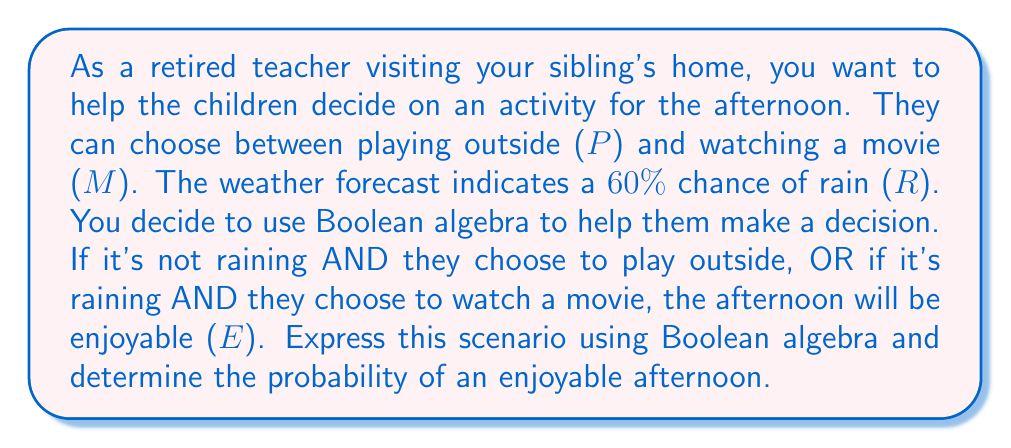Could you help me with this problem? Let's approach this step-by-step using Boolean algebra:

1. Define the variables:
   P: Playing outside
   M: Watching a movie
   R: Raining
   E: Enjoyable afternoon

2. Express the scenario in Boolean algebra:
   $E = (P \land \overline{R}) \lor (M \land R)$

3. We know the probability of rain is 60%, so:
   $P(R) = 0.6$
   $P(\overline{R}) = 1 - P(R) = 0.4$

4. Assume the children are equally likely to choose playing outside or watching a movie:
   $P(P) = P(M) = 0.5$

5. Calculate the probability of an enjoyable afternoon:
   $P(E) = P((P \land \overline{R}) \lor (M \land R))$
   
   $= P(P \land \overline{R}) + P(M \land R)$ (sum rule, as events are mutually exclusive)
   
   $= P(P) \cdot P(\overline{R}) + P(M) \cdot P(R)$ (multiplication rule, as events are independent)
   
   $= 0.5 \cdot 0.4 + 0.5 \cdot 0.6$
   
   $= 0.2 + 0.3$
   
   $= 0.5$

Therefore, the probability of an enjoyable afternoon is 0.5 or 50%.
Answer: 0.5 